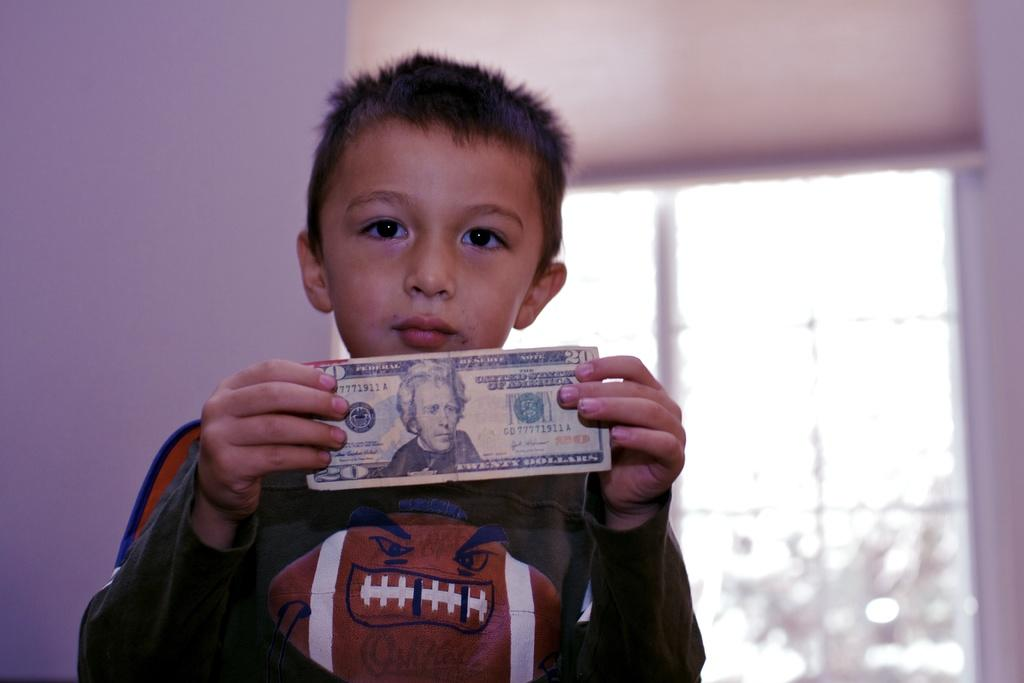<image>
Provide a brief description of the given image. A young boy holds up a twenty dollar bill from the United States of America over a football. 